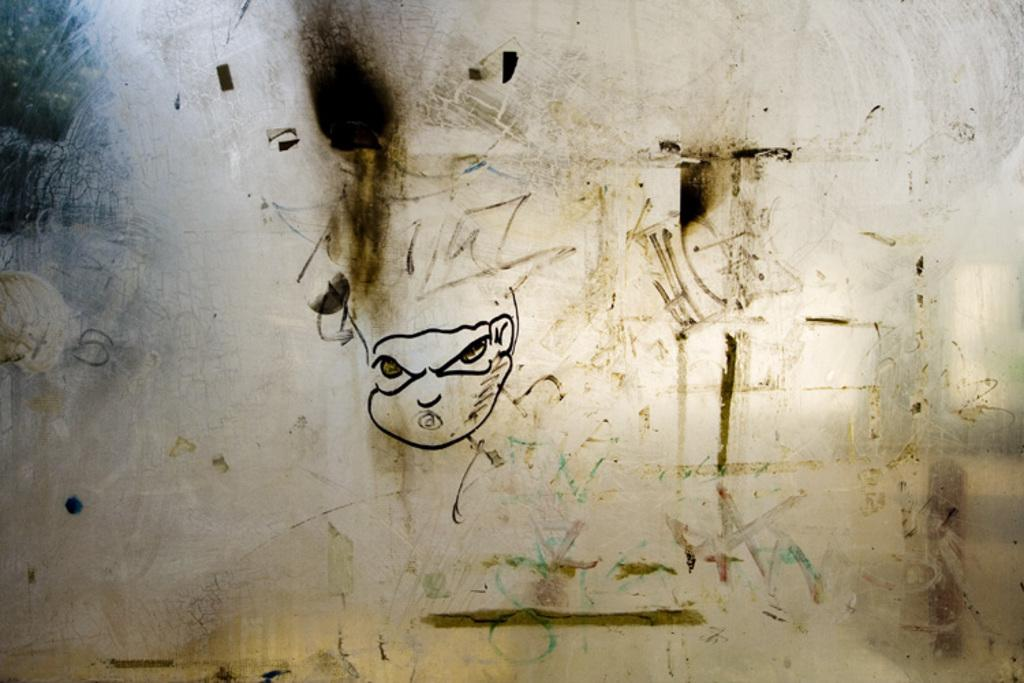What is depicted on the glass in the image? There is an art on the glass in the image. What type of sock is being used as a representative in the image? There is no sock present in the image, and no representative can be identified from the provided fact. 